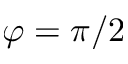<formula> <loc_0><loc_0><loc_500><loc_500>\varphi = \pi / 2</formula> 